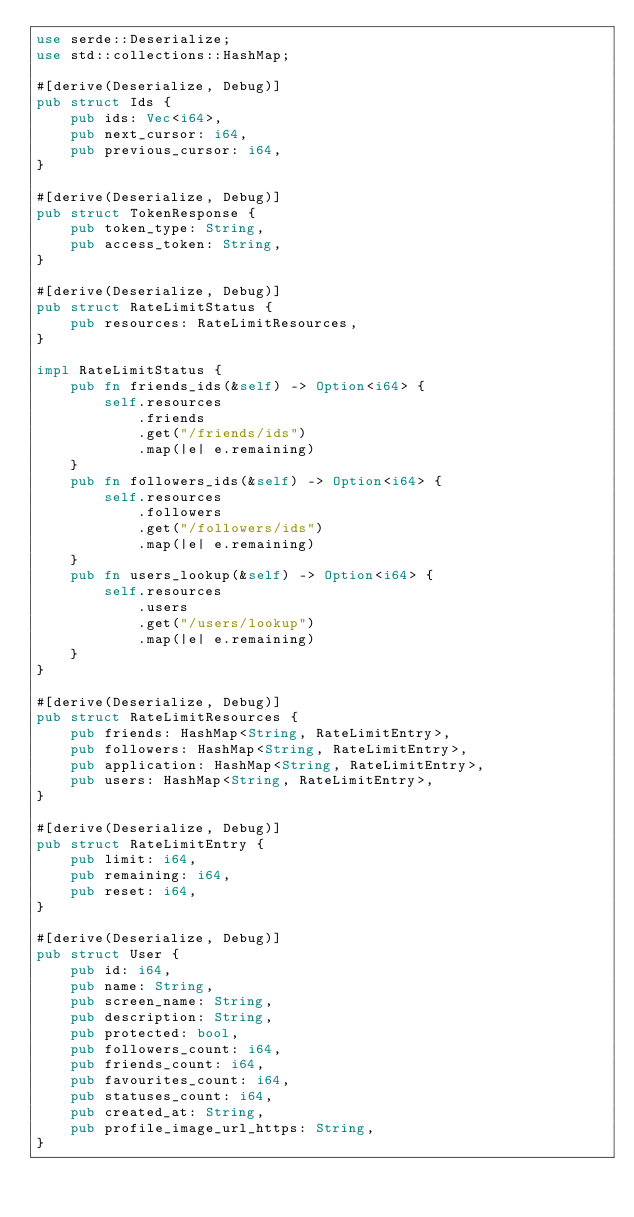<code> <loc_0><loc_0><loc_500><loc_500><_Rust_>use serde::Deserialize;
use std::collections::HashMap;

#[derive(Deserialize, Debug)]
pub struct Ids {
    pub ids: Vec<i64>,
    pub next_cursor: i64,
    pub previous_cursor: i64,
}

#[derive(Deserialize, Debug)]
pub struct TokenResponse {
    pub token_type: String,
    pub access_token: String,
}

#[derive(Deserialize, Debug)]
pub struct RateLimitStatus {
    pub resources: RateLimitResources,
}

impl RateLimitStatus {
    pub fn friends_ids(&self) -> Option<i64> {
        self.resources
            .friends
            .get("/friends/ids")
            .map(|e| e.remaining)
    }
    pub fn followers_ids(&self) -> Option<i64> {
        self.resources
            .followers
            .get("/followers/ids")
            .map(|e| e.remaining)
    }
    pub fn users_lookup(&self) -> Option<i64> {
        self.resources
            .users
            .get("/users/lookup")
            .map(|e| e.remaining)
    }
}

#[derive(Deserialize, Debug)]
pub struct RateLimitResources {
    pub friends: HashMap<String, RateLimitEntry>,
    pub followers: HashMap<String, RateLimitEntry>,
    pub application: HashMap<String, RateLimitEntry>,
    pub users: HashMap<String, RateLimitEntry>,
}

#[derive(Deserialize, Debug)]
pub struct RateLimitEntry {
    pub limit: i64,
    pub remaining: i64,
    pub reset: i64,
}

#[derive(Deserialize, Debug)]
pub struct User {
    pub id: i64,
    pub name: String,
    pub screen_name: String,
    pub description: String,
    pub protected: bool,
    pub followers_count: i64,
    pub friends_count: i64,
    pub favourites_count: i64,
    pub statuses_count: i64,
    pub created_at: String,
    pub profile_image_url_https: String,
}
</code> 